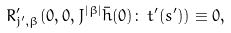Convert formula to latex. <formula><loc_0><loc_0><loc_500><loc_500>R _ { j ^ { \prime } , \beta } ^ { \prime } ( 0 , 0 , J ^ { | \beta | } \bar { h } ( 0 ) \colon \, t ^ { \prime } ( s ^ { \prime } ) ) \equiv 0 ,</formula> 